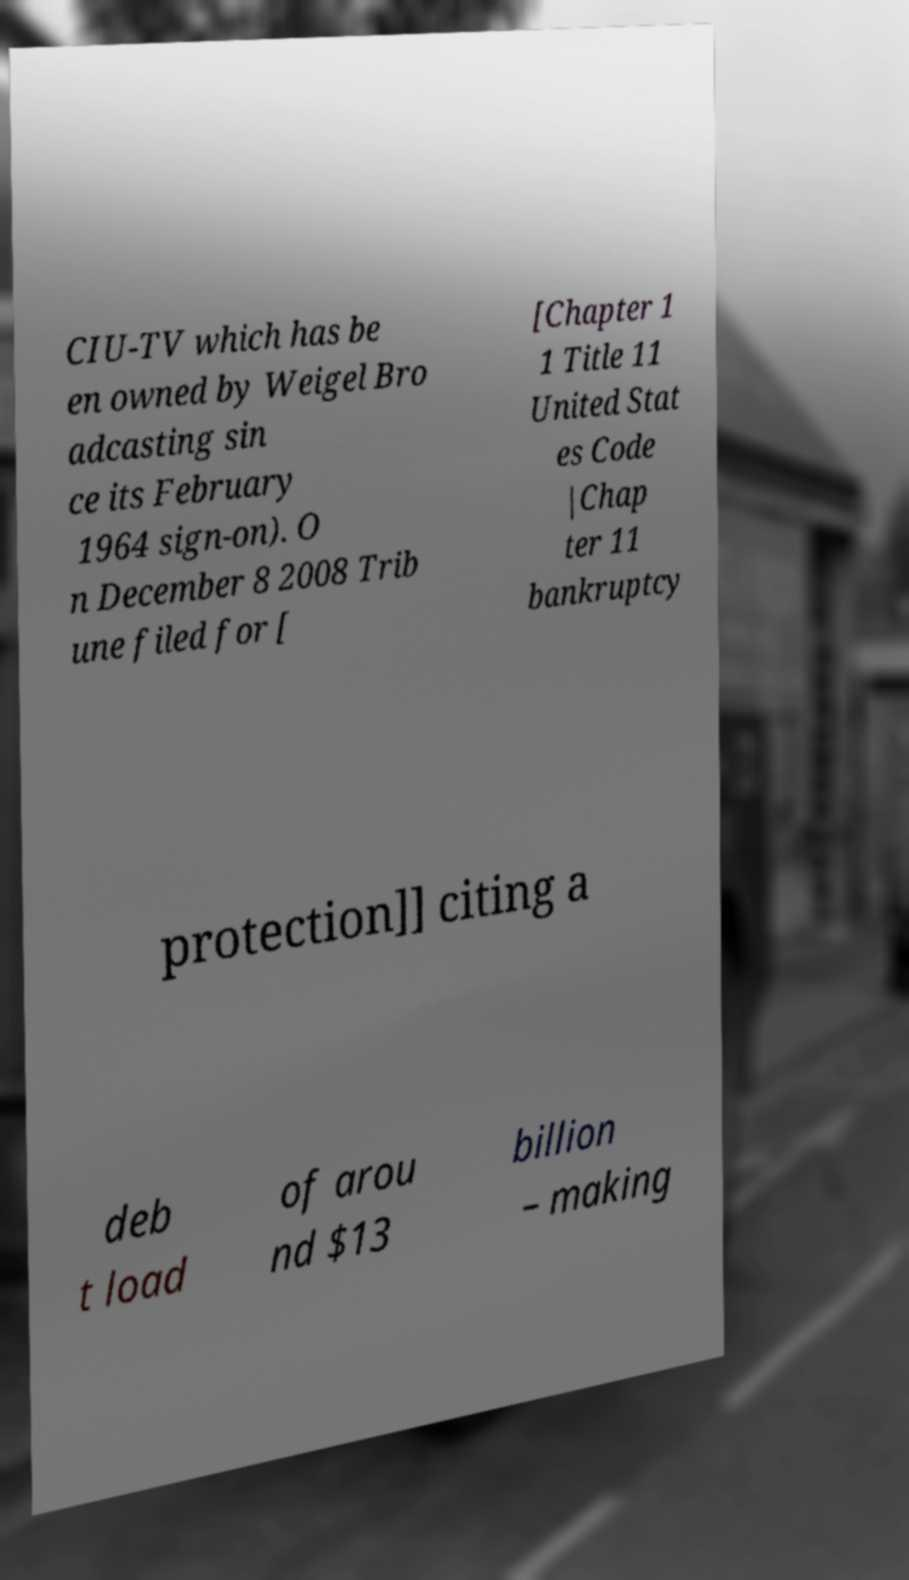What messages or text are displayed in this image? I need them in a readable, typed format. CIU-TV which has be en owned by Weigel Bro adcasting sin ce its February 1964 sign-on). O n December 8 2008 Trib une filed for [ [Chapter 1 1 Title 11 United Stat es Code |Chap ter 11 bankruptcy protection]] citing a deb t load of arou nd $13 billion – making 